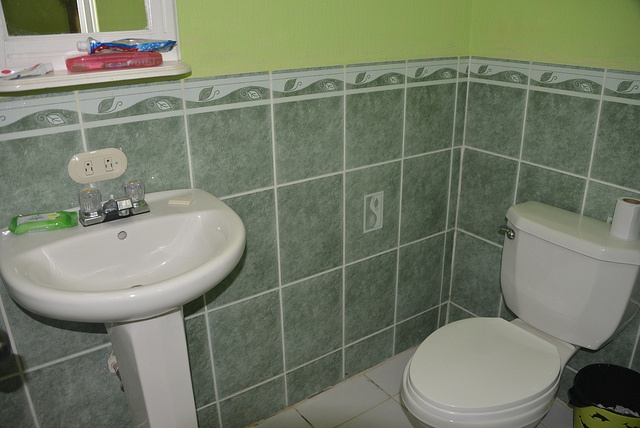Describe the objects in this image and their specific colors. I can see toilet in gray and darkgray tones, sink in gray, darkgray, and lightgray tones, toothbrush in gray, darkgray, blue, and maroon tones, and toothbrush in gray, brown, and salmon tones in this image. 